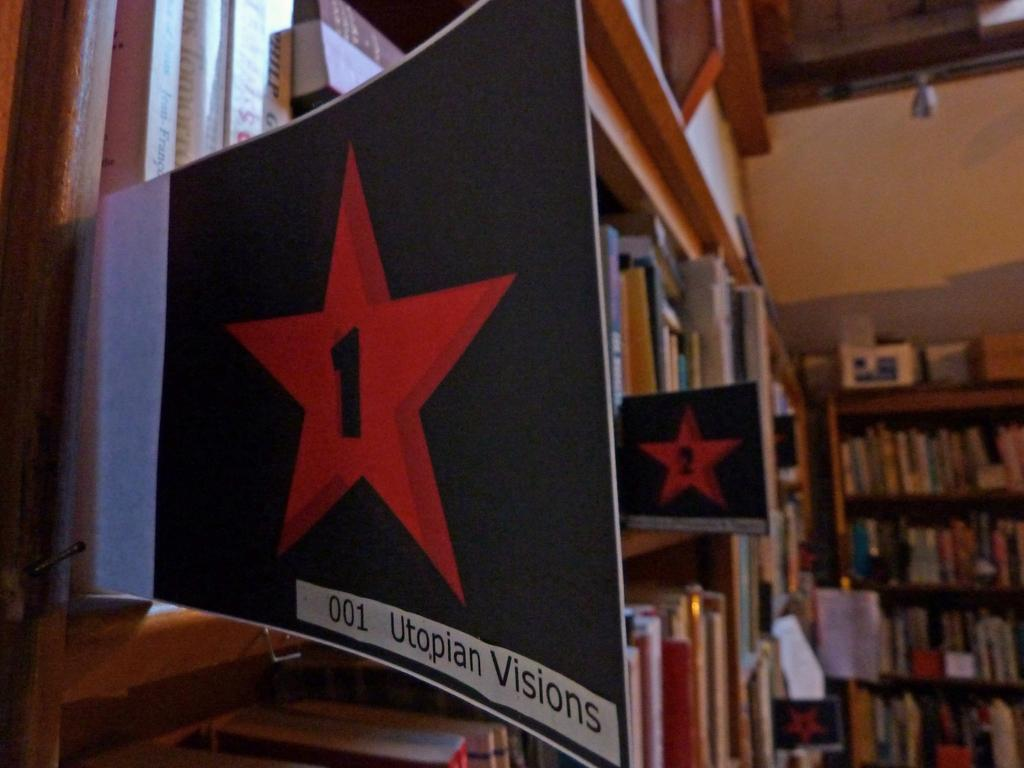<image>
Share a concise interpretation of the image provided. A star on the side of shelves has the number 1 on it. 